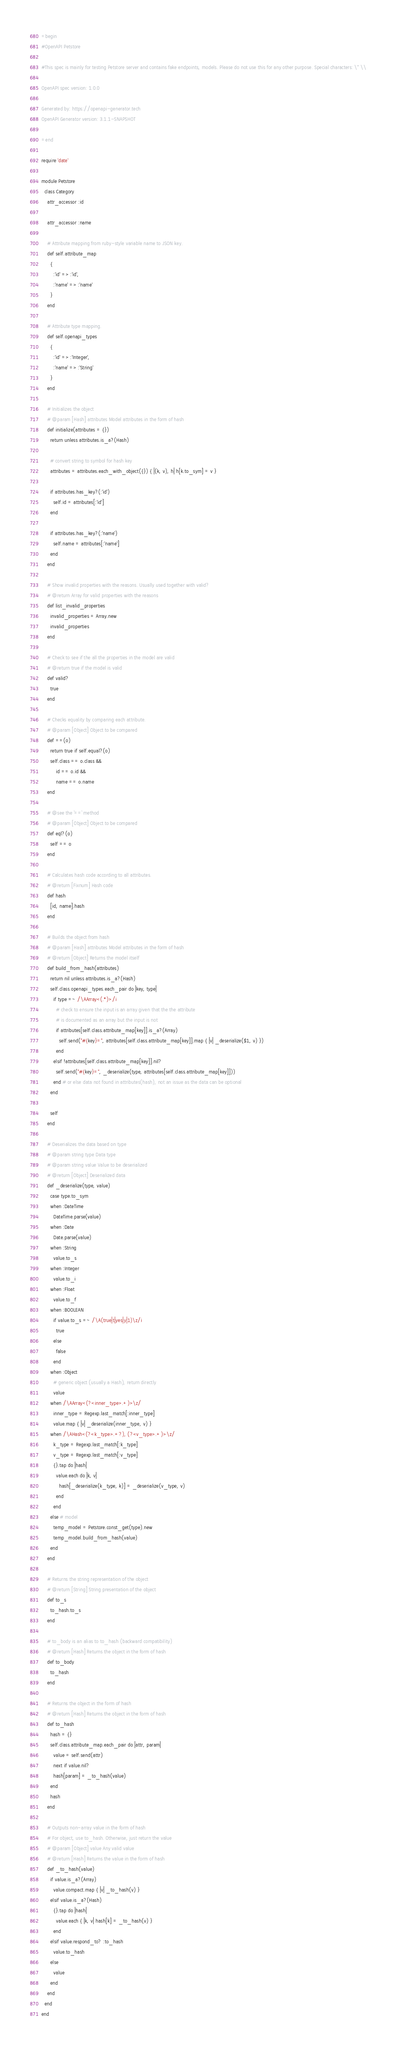Convert code to text. <code><loc_0><loc_0><loc_500><loc_500><_Ruby_>=begin
#OpenAPI Petstore

#This spec is mainly for testing Petstore server and contains fake endpoints, models. Please do not use this for any other purpose. Special characters: \" \\

OpenAPI spec version: 1.0.0

Generated by: https://openapi-generator.tech
OpenAPI Generator version: 3.1.1-SNAPSHOT

=end

require 'date'

module Petstore
  class Category
    attr_accessor :id

    attr_accessor :name

    # Attribute mapping from ruby-style variable name to JSON key.
    def self.attribute_map
      {
        :'id' => :'id',
        :'name' => :'name'
      }
    end

    # Attribute type mapping.
    def self.openapi_types
      {
        :'id' => :'Integer',
        :'name' => :'String'
      }
    end

    # Initializes the object
    # @param [Hash] attributes Model attributes in the form of hash
    def initialize(attributes = {})
      return unless attributes.is_a?(Hash)

      # convert string to symbol for hash key
      attributes = attributes.each_with_object({}) { |(k, v), h| h[k.to_sym] = v }

      if attributes.has_key?(:'id')
        self.id = attributes[:'id']
      end

      if attributes.has_key?(:'name')
        self.name = attributes[:'name']
      end
    end

    # Show invalid properties with the reasons. Usually used together with valid?
    # @return Array for valid properties with the reasons
    def list_invalid_properties
      invalid_properties = Array.new
      invalid_properties
    end

    # Check to see if the all the properties in the model are valid
    # @return true if the model is valid
    def valid?
      true
    end

    # Checks equality by comparing each attribute.
    # @param [Object] Object to be compared
    def ==(o)
      return true if self.equal?(o)
      self.class == o.class &&
          id == o.id &&
          name == o.name
    end

    # @see the `==` method
    # @param [Object] Object to be compared
    def eql?(o)
      self == o
    end

    # Calculates hash code according to all attributes.
    # @return [Fixnum] Hash code
    def hash
      [id, name].hash
    end

    # Builds the object from hash
    # @param [Hash] attributes Model attributes in the form of hash
    # @return [Object] Returns the model itself
    def build_from_hash(attributes)
      return nil unless attributes.is_a?(Hash)
      self.class.openapi_types.each_pair do |key, type|
        if type =~ /\AArray<(.*)>/i
          # check to ensure the input is an array given that the the attribute
          # is documented as an array but the input is not
          if attributes[self.class.attribute_map[key]].is_a?(Array)
            self.send("#{key}=", attributes[self.class.attribute_map[key]].map { |v| _deserialize($1, v) })
          end
        elsif !attributes[self.class.attribute_map[key]].nil?
          self.send("#{key}=", _deserialize(type, attributes[self.class.attribute_map[key]]))
        end # or else data not found in attributes(hash), not an issue as the data can be optional
      end

      self
    end

    # Deserializes the data based on type
    # @param string type Data type
    # @param string value Value to be deserialized
    # @return [Object] Deserialized data
    def _deserialize(type, value)
      case type.to_sym
      when :DateTime
        DateTime.parse(value)
      when :Date
        Date.parse(value)
      when :String
        value.to_s
      when :Integer
        value.to_i
      when :Float
        value.to_f
      when :BOOLEAN
        if value.to_s =~ /\A(true|t|yes|y|1)\z/i
          true
        else
          false
        end
      when :Object
        # generic object (usually a Hash), return directly
        value
      when /\AArray<(?<inner_type>.+)>\z/
        inner_type = Regexp.last_match[:inner_type]
        value.map { |v| _deserialize(inner_type, v) }
      when /\AHash<(?<k_type>.+?), (?<v_type>.+)>\z/
        k_type = Regexp.last_match[:k_type]
        v_type = Regexp.last_match[:v_type]
        {}.tap do |hash|
          value.each do |k, v|
            hash[_deserialize(k_type, k)] = _deserialize(v_type, v)
          end
        end
      else # model
        temp_model = Petstore.const_get(type).new
        temp_model.build_from_hash(value)
      end
    end

    # Returns the string representation of the object
    # @return [String] String presentation of the object
    def to_s
      to_hash.to_s
    end

    # to_body is an alias to to_hash (backward compatibility)
    # @return [Hash] Returns the object in the form of hash
    def to_body
      to_hash
    end

    # Returns the object in the form of hash
    # @return [Hash] Returns the object in the form of hash
    def to_hash
      hash = {}
      self.class.attribute_map.each_pair do |attr, param|
        value = self.send(attr)
        next if value.nil?
        hash[param] = _to_hash(value)
      end
      hash
    end

    # Outputs non-array value in the form of hash
    # For object, use to_hash. Otherwise, just return the value
    # @param [Object] value Any valid value
    # @return [Hash] Returns the value in the form of hash
    def _to_hash(value)
      if value.is_a?(Array)
        value.compact.map { |v| _to_hash(v) }
      elsif value.is_a?(Hash)
        {}.tap do |hash|
          value.each { |k, v| hash[k] = _to_hash(v) }
        end
      elsif value.respond_to? :to_hash
        value.to_hash
      else
        value
      end
    end
  end
end
</code> 